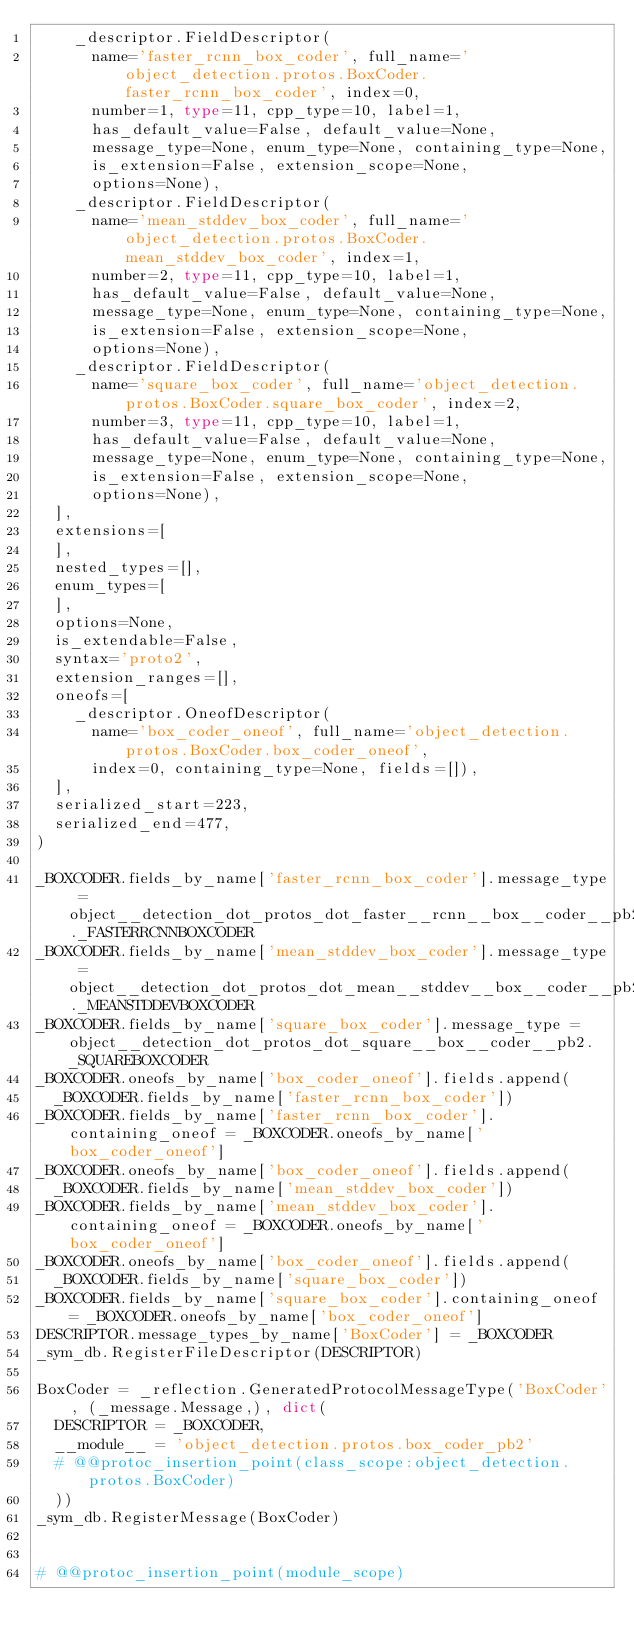Convert code to text. <code><loc_0><loc_0><loc_500><loc_500><_Python_>    _descriptor.FieldDescriptor(
      name='faster_rcnn_box_coder', full_name='object_detection.protos.BoxCoder.faster_rcnn_box_coder', index=0,
      number=1, type=11, cpp_type=10, label=1,
      has_default_value=False, default_value=None,
      message_type=None, enum_type=None, containing_type=None,
      is_extension=False, extension_scope=None,
      options=None),
    _descriptor.FieldDescriptor(
      name='mean_stddev_box_coder', full_name='object_detection.protos.BoxCoder.mean_stddev_box_coder', index=1,
      number=2, type=11, cpp_type=10, label=1,
      has_default_value=False, default_value=None,
      message_type=None, enum_type=None, containing_type=None,
      is_extension=False, extension_scope=None,
      options=None),
    _descriptor.FieldDescriptor(
      name='square_box_coder', full_name='object_detection.protos.BoxCoder.square_box_coder', index=2,
      number=3, type=11, cpp_type=10, label=1,
      has_default_value=False, default_value=None,
      message_type=None, enum_type=None, containing_type=None,
      is_extension=False, extension_scope=None,
      options=None),
  ],
  extensions=[
  ],
  nested_types=[],
  enum_types=[
  ],
  options=None,
  is_extendable=False,
  syntax='proto2',
  extension_ranges=[],
  oneofs=[
    _descriptor.OneofDescriptor(
      name='box_coder_oneof', full_name='object_detection.protos.BoxCoder.box_coder_oneof',
      index=0, containing_type=None, fields=[]),
  ],
  serialized_start=223,
  serialized_end=477,
)

_BOXCODER.fields_by_name['faster_rcnn_box_coder'].message_type = object__detection_dot_protos_dot_faster__rcnn__box__coder__pb2._FASTERRCNNBOXCODER
_BOXCODER.fields_by_name['mean_stddev_box_coder'].message_type = object__detection_dot_protos_dot_mean__stddev__box__coder__pb2._MEANSTDDEVBOXCODER
_BOXCODER.fields_by_name['square_box_coder'].message_type = object__detection_dot_protos_dot_square__box__coder__pb2._SQUAREBOXCODER
_BOXCODER.oneofs_by_name['box_coder_oneof'].fields.append(
  _BOXCODER.fields_by_name['faster_rcnn_box_coder'])
_BOXCODER.fields_by_name['faster_rcnn_box_coder'].containing_oneof = _BOXCODER.oneofs_by_name['box_coder_oneof']
_BOXCODER.oneofs_by_name['box_coder_oneof'].fields.append(
  _BOXCODER.fields_by_name['mean_stddev_box_coder'])
_BOXCODER.fields_by_name['mean_stddev_box_coder'].containing_oneof = _BOXCODER.oneofs_by_name['box_coder_oneof']
_BOXCODER.oneofs_by_name['box_coder_oneof'].fields.append(
  _BOXCODER.fields_by_name['square_box_coder'])
_BOXCODER.fields_by_name['square_box_coder'].containing_oneof = _BOXCODER.oneofs_by_name['box_coder_oneof']
DESCRIPTOR.message_types_by_name['BoxCoder'] = _BOXCODER
_sym_db.RegisterFileDescriptor(DESCRIPTOR)

BoxCoder = _reflection.GeneratedProtocolMessageType('BoxCoder', (_message.Message,), dict(
  DESCRIPTOR = _BOXCODER,
  __module__ = 'object_detection.protos.box_coder_pb2'
  # @@protoc_insertion_point(class_scope:object_detection.protos.BoxCoder)
  ))
_sym_db.RegisterMessage(BoxCoder)


# @@protoc_insertion_point(module_scope)
</code> 